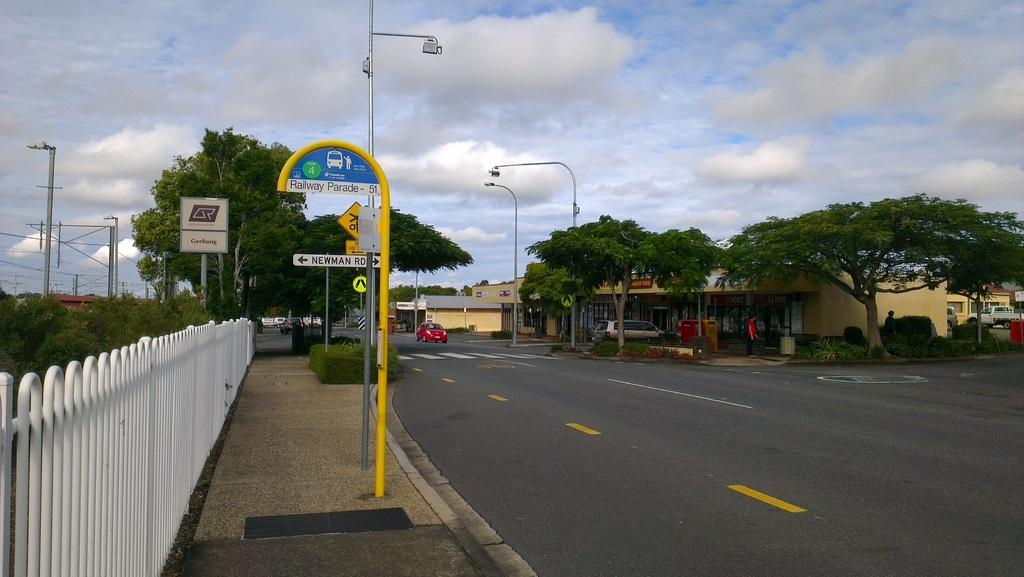<image>
Relay a brief, clear account of the picture shown. On the left side of the road there is a Railway Parade sign in front of Newman Road. 